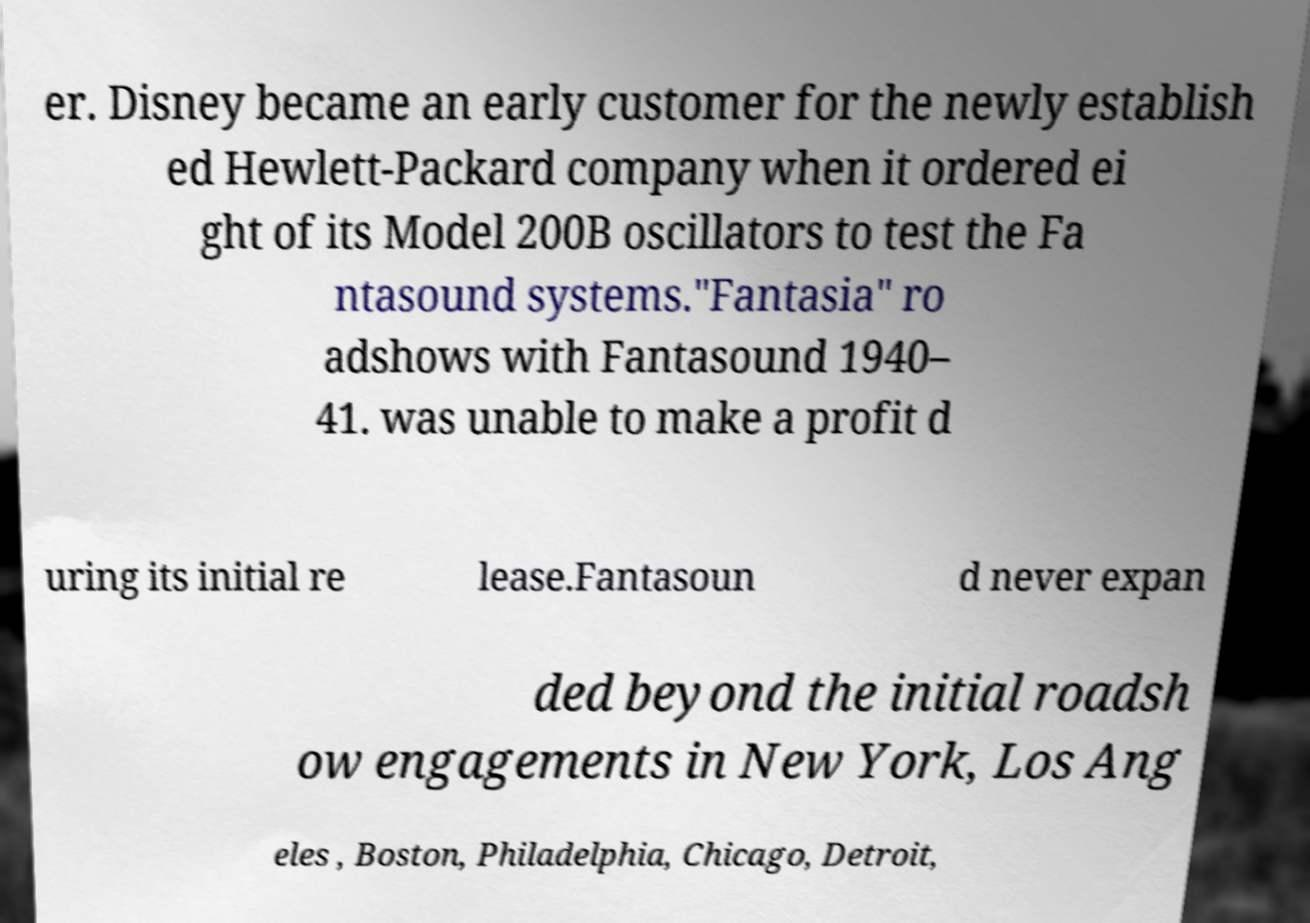Please identify and transcribe the text found in this image. er. Disney became an early customer for the newly establish ed Hewlett-Packard company when it ordered ei ght of its Model 200B oscillators to test the Fa ntasound systems."Fantasia" ro adshows with Fantasound 1940– 41. was unable to make a profit d uring its initial re lease.Fantasoun d never expan ded beyond the initial roadsh ow engagements in New York, Los Ang eles , Boston, Philadelphia, Chicago, Detroit, 